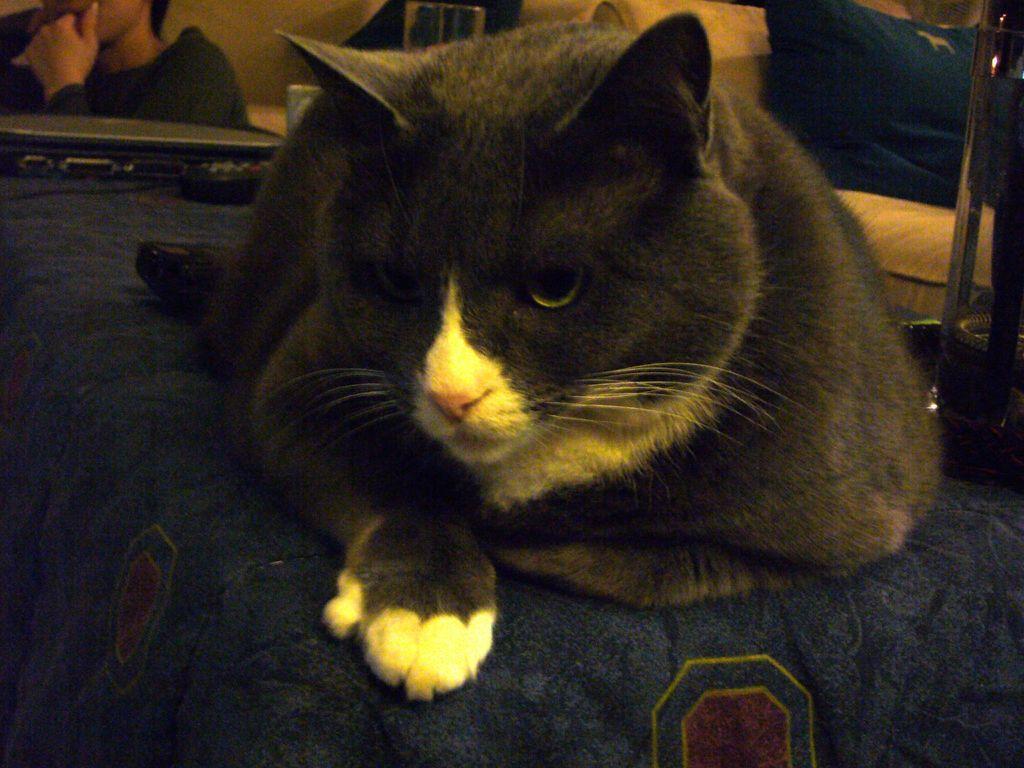Please provide a concise description of this image. In the foreground of this image, there is a cat and it seems like it is on a table. In the background, there is a person, remote, glass, an electronic device, bed and an object on the right side. 